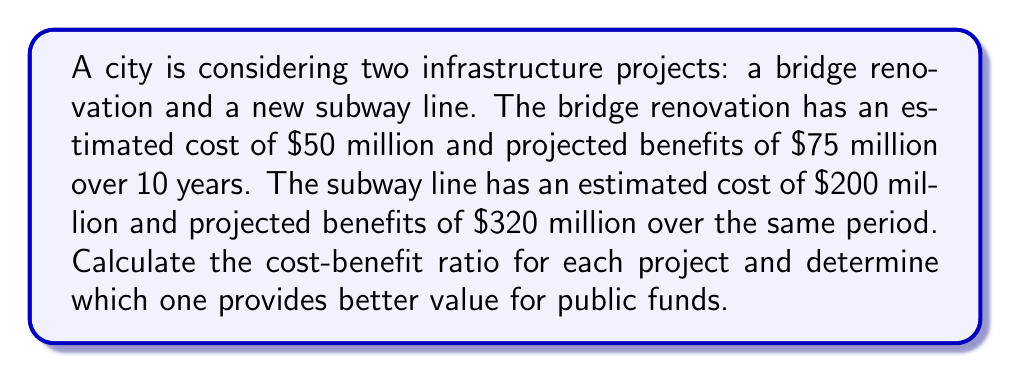What is the answer to this math problem? To calculate the cost-benefit ratio for each project, we use the formula:

$$ \text{Cost-Benefit Ratio} = \frac{\text{Total Benefits}}{\text{Total Costs}} $$

1. Bridge Renovation:
   $$ \text{Cost-Benefit Ratio}_{\text{Bridge}} = \frac{\$75\text{ million}}{\$50\text{ million}} = 1.5 $$

2. Subway Line:
   $$ \text{Cost-Benefit Ratio}_{\text{Subway}} = \frac{\$320\text{ million}}{\$200\text{ million}} = 1.6 $$

Both projects have a cost-benefit ratio greater than 1, indicating that they are both economically viable. However, the subway line has a slightly higher ratio of 1.6 compared to the bridge renovation's 1.5.

To determine which project provides better value for public funds, we compare the two ratios:

$$ 1.6 > 1.5 $$

Therefore, the subway line project provides better value for public funds based on the cost-benefit analysis.
Answer: Subway line (ratio: 1.6) provides better value than bridge renovation (ratio: 1.5). 